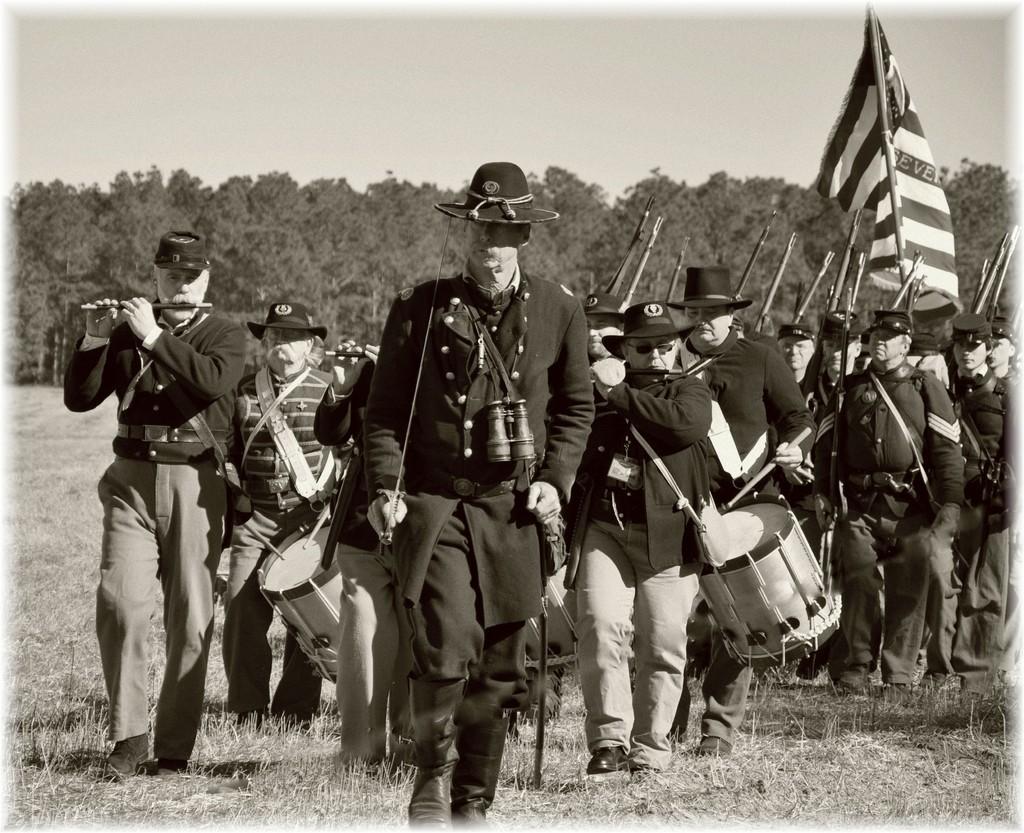Could you give a brief overview of what you see in this image? This picture is clicked outside. In the foreground we can see the group of people holding some objects and seems to be walking and we can see the flag. In the background we can see the sky, trees and the grass. 